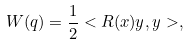<formula> <loc_0><loc_0><loc_500><loc_500>W ( q ) = \frac { 1 } { 2 } < R ( x ) y , y > ,</formula> 